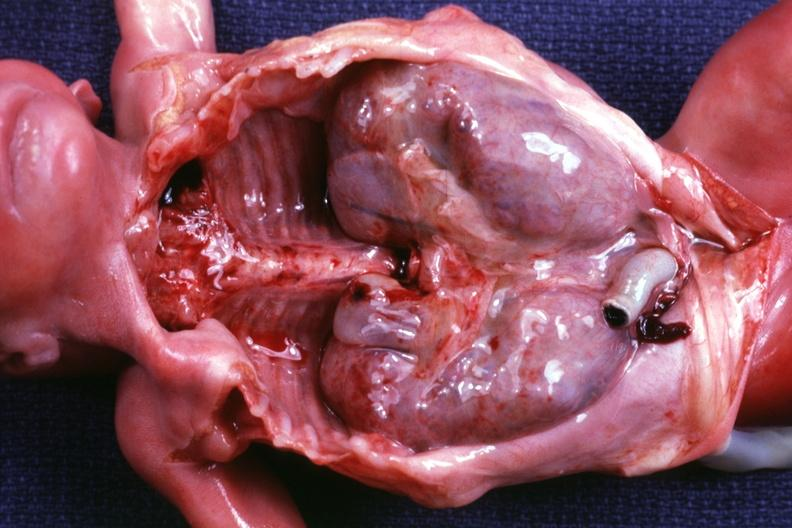what does this image show?
Answer the question using a single word or phrase. Kidneys in situ with other organs removed dramatic demonstration of size of kidneys 